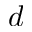<formula> <loc_0><loc_0><loc_500><loc_500>d</formula> 